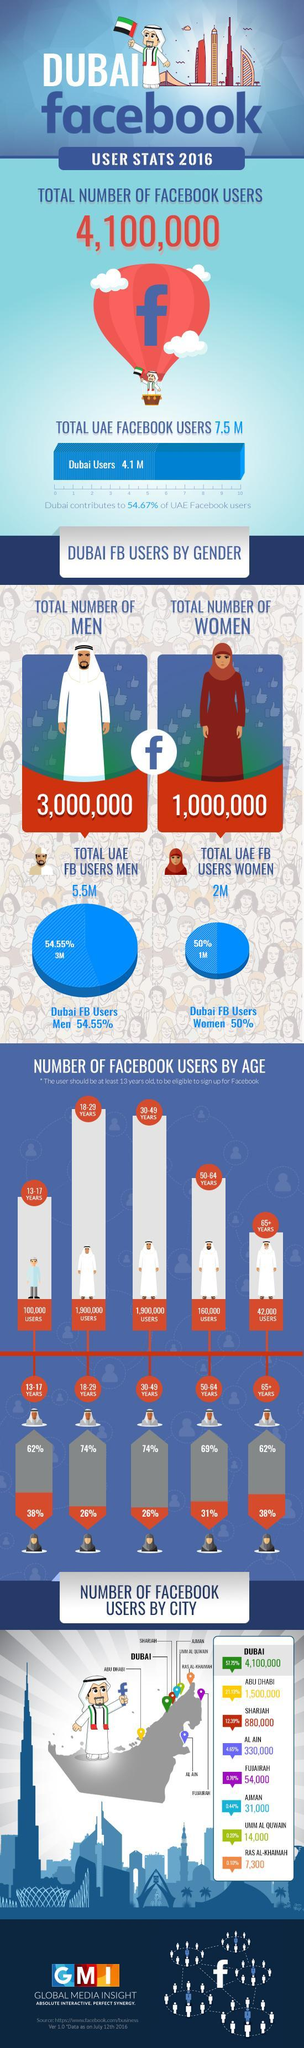How many cities in UAE contribute less than one million Facebook users?
Answer the question with a short phrase. 6 what percent of Facebook users from the age group 50-64 are women? 31% what is the total number of Facebook users from Dubai and Abu Dhabi taken together? 5600000 which age group is more active on Facebook? 18-29 years which age group is less active on Facebook? 65+ what is the total number of Facebook users above 30? 2102000 what is the total number of Facebook users under 30? 2900000 Which region in the UAE contributes the most Facebook users? Dubai what are the cities in UAE which contribute more than one million Facebook users? Dubai, Abu Dhabi Which city in UAE contribute least number of Facebook users? Ras Al-Khaimah 